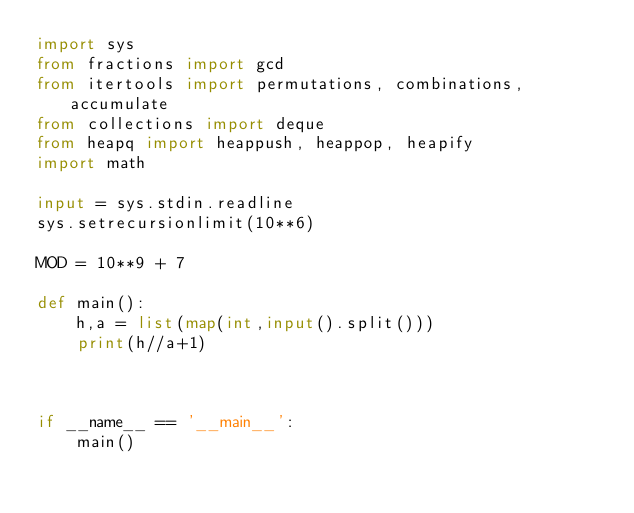Convert code to text. <code><loc_0><loc_0><loc_500><loc_500><_Python_>import sys
from fractions import gcd
from itertools import permutations, combinations, accumulate
from collections import deque
from heapq import heappush, heappop, heapify
import math

input = sys.stdin.readline
sys.setrecursionlimit(10**6)

MOD = 10**9 + 7

def main():
    h,a = list(map(int,input().split()))
    print(h//a+1)



if __name__ == '__main__':
    main()</code> 